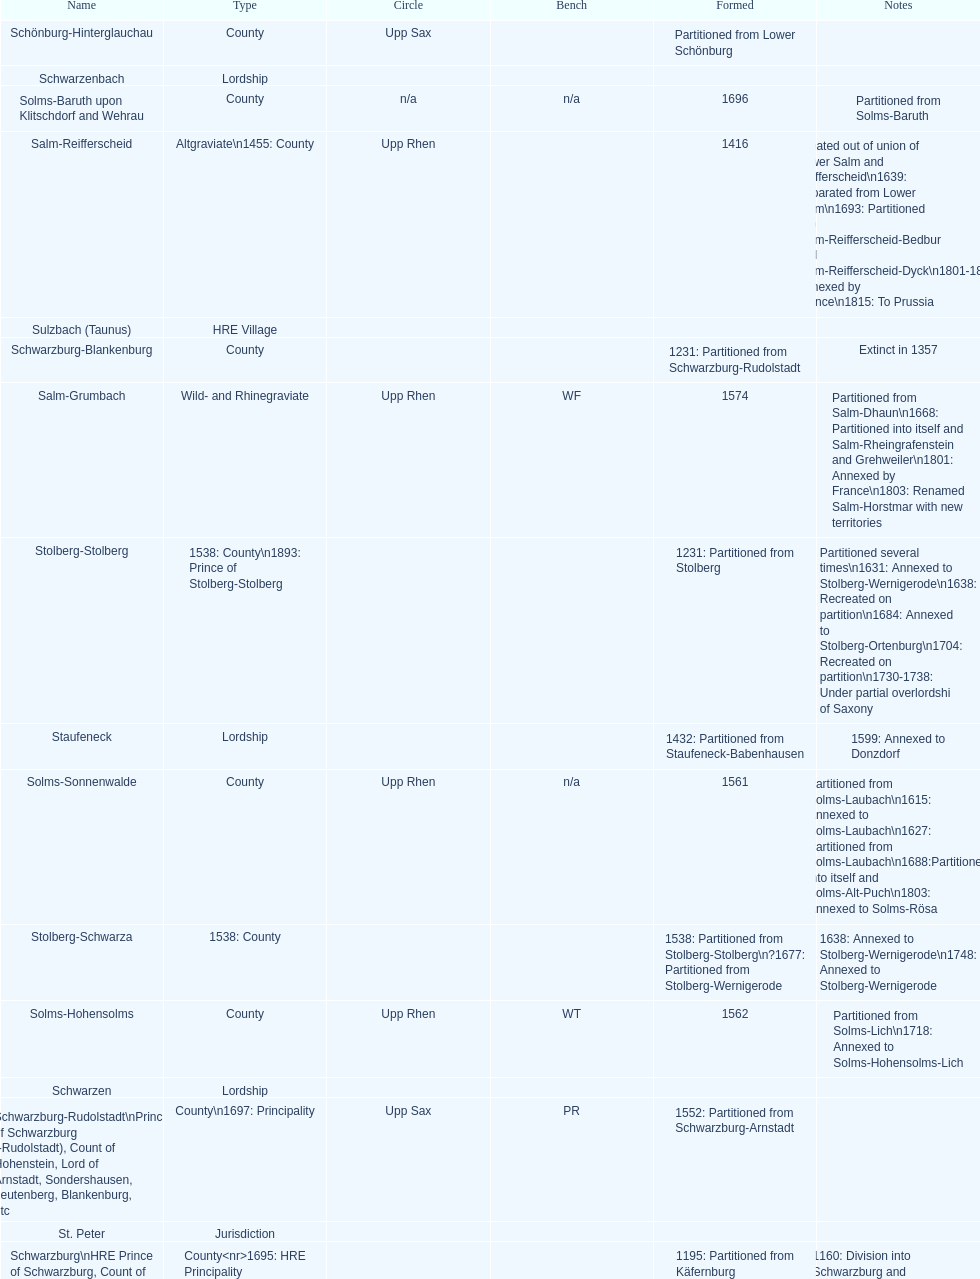Which bench is represented the most? PR. 